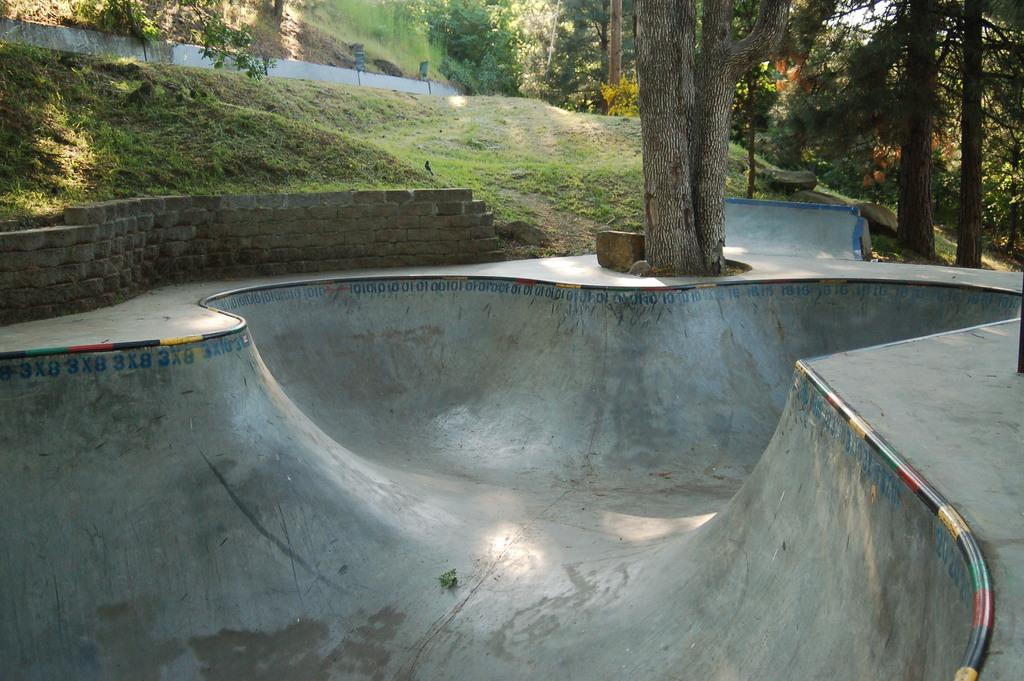What is located in the foreground of the image? There is an empty pond in the foreground of the image. What can be seen in the background of the image? There are trees, a tiny wall, and grassland in the background of the image. What type of machine is visible on top of the hill in the image? There is no hill or machine present in the image. 